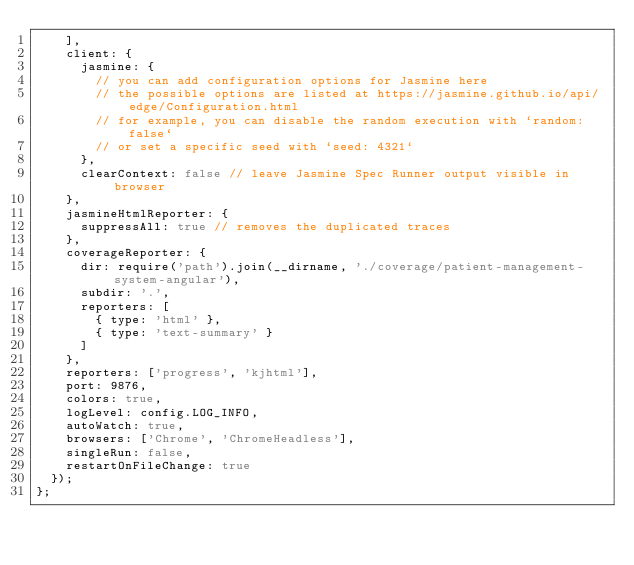Convert code to text. <code><loc_0><loc_0><loc_500><loc_500><_JavaScript_>    ],
    client: {
      jasmine: {
        // you can add configuration options for Jasmine here
        // the possible options are listed at https://jasmine.github.io/api/edge/Configuration.html
        // for example, you can disable the random execution with `random: false`
        // or set a specific seed with `seed: 4321`
      },
      clearContext: false // leave Jasmine Spec Runner output visible in browser
    },
    jasmineHtmlReporter: {
      suppressAll: true // removes the duplicated traces
    },
    coverageReporter: {
      dir: require('path').join(__dirname, './coverage/patient-management-system-angular'),
      subdir: '.',
      reporters: [
        { type: 'html' },
        { type: 'text-summary' }
      ]
    },
    reporters: ['progress', 'kjhtml'],
    port: 9876,
    colors: true,
    logLevel: config.LOG_INFO,
    autoWatch: true,
    browsers: ['Chrome', 'ChromeHeadless'],
    singleRun: false,
    restartOnFileChange: true
  });
};
</code> 